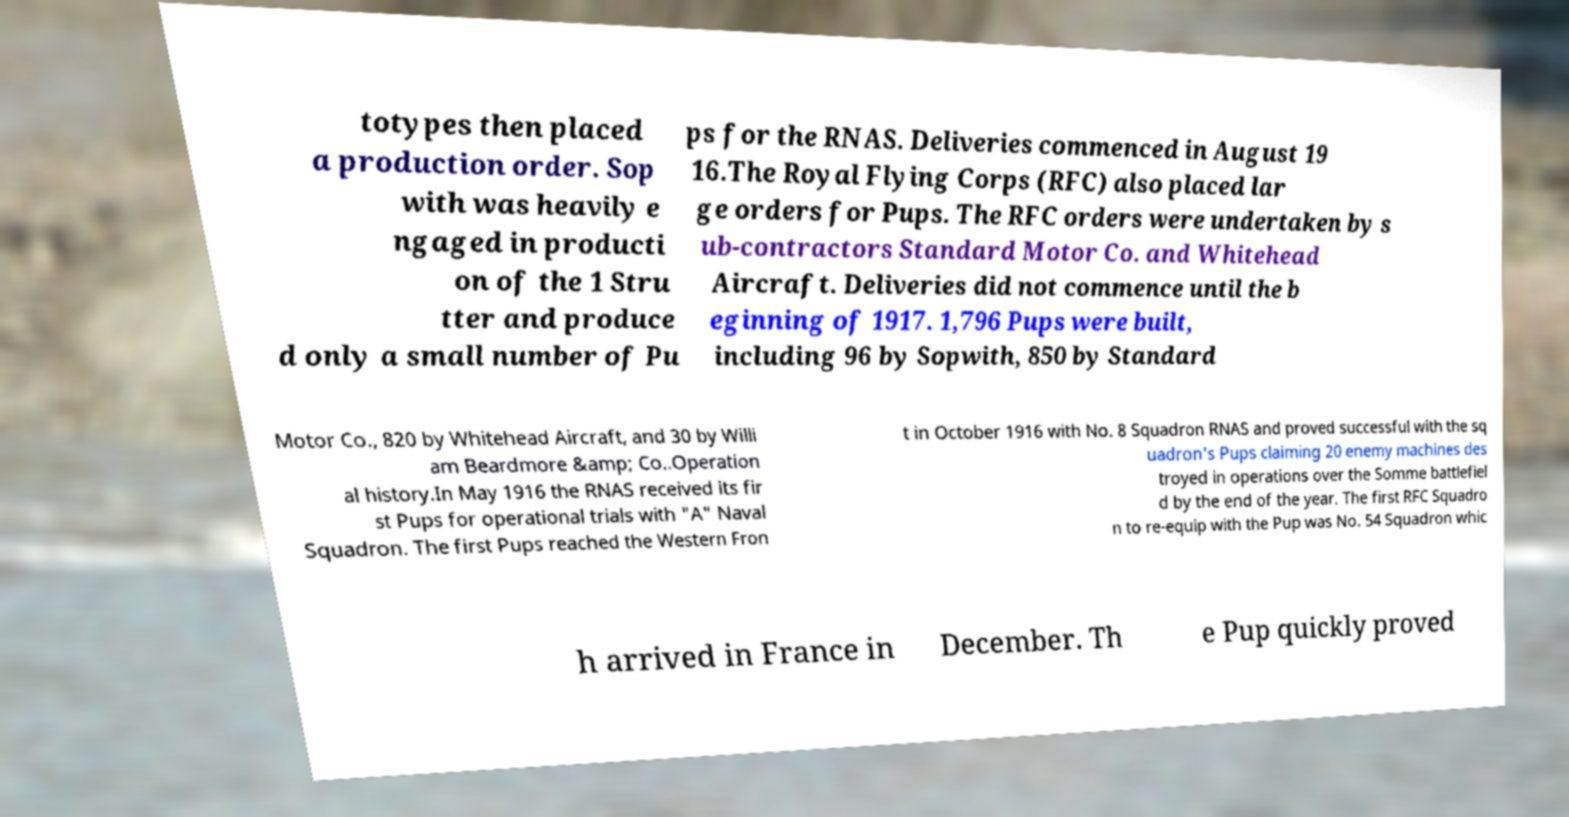What messages or text are displayed in this image? I need them in a readable, typed format. totypes then placed a production order. Sop with was heavily e ngaged in producti on of the 1 Stru tter and produce d only a small number of Pu ps for the RNAS. Deliveries commenced in August 19 16.The Royal Flying Corps (RFC) also placed lar ge orders for Pups. The RFC orders were undertaken by s ub-contractors Standard Motor Co. and Whitehead Aircraft. Deliveries did not commence until the b eginning of 1917. 1,796 Pups were built, including 96 by Sopwith, 850 by Standard Motor Co., 820 by Whitehead Aircraft, and 30 by Willi am Beardmore &amp; Co..Operation al history.In May 1916 the RNAS received its fir st Pups for operational trials with "A" Naval Squadron. The first Pups reached the Western Fron t in October 1916 with No. 8 Squadron RNAS and proved successful with the sq uadron's Pups claiming 20 enemy machines des troyed in operations over the Somme battlefiel d by the end of the year. The first RFC Squadro n to re-equip with the Pup was No. 54 Squadron whic h arrived in France in December. Th e Pup quickly proved 